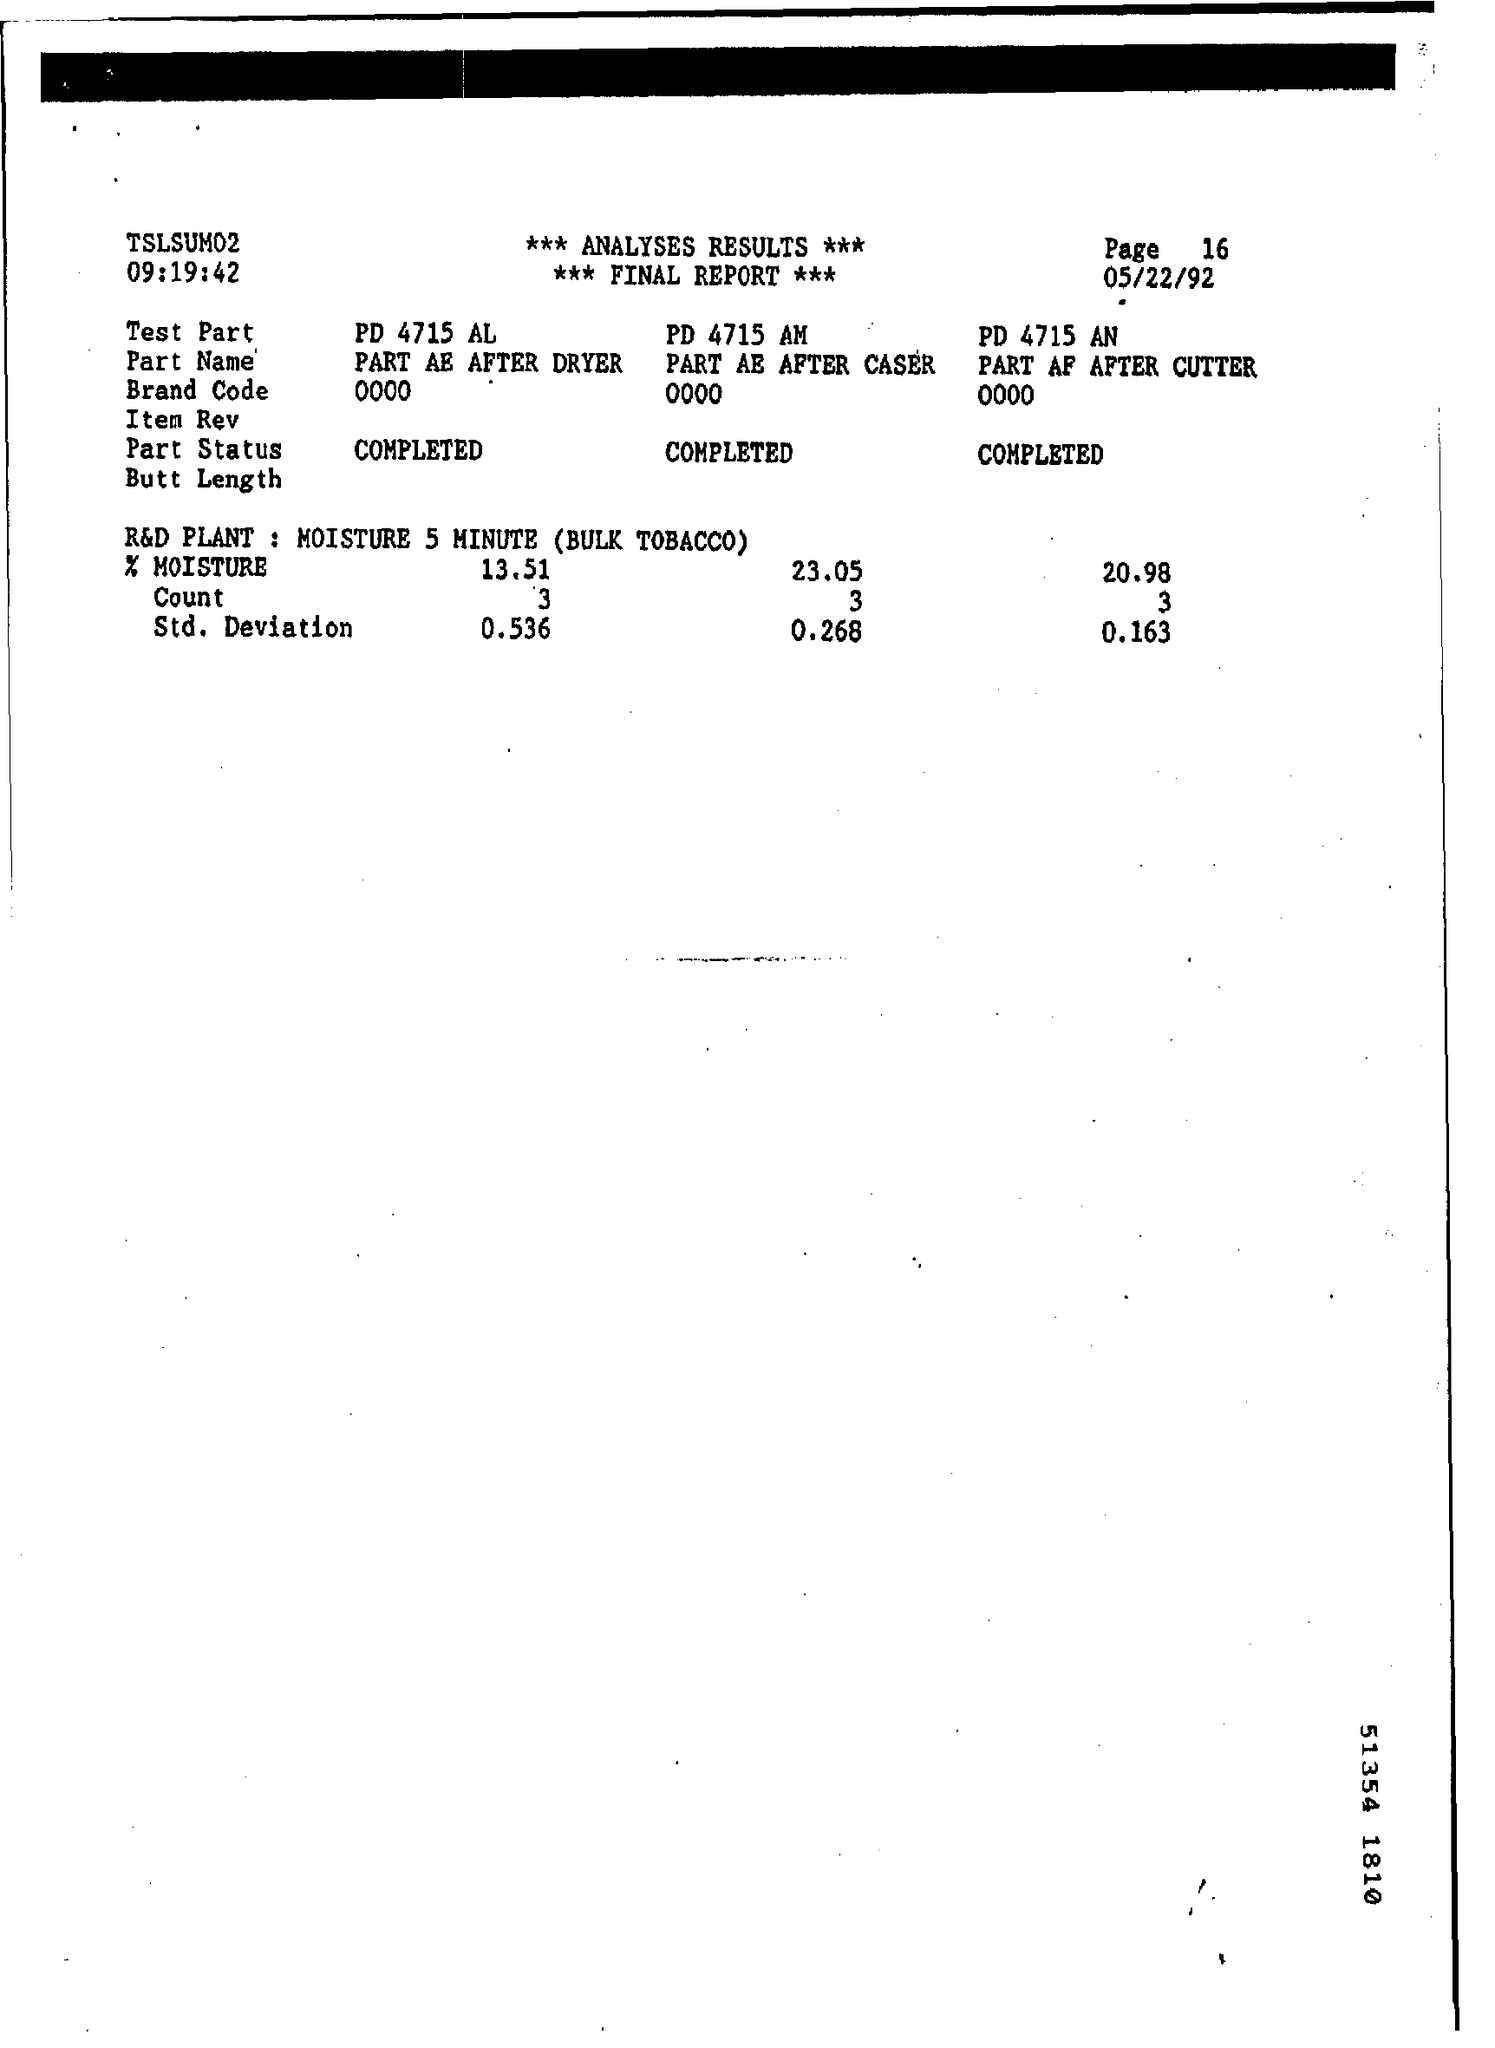What is the date mentioned?
Offer a terse response. 05/22/92. What is the name of the Plant mentioned at last?
Ensure brevity in your answer.  R&D Plant. 